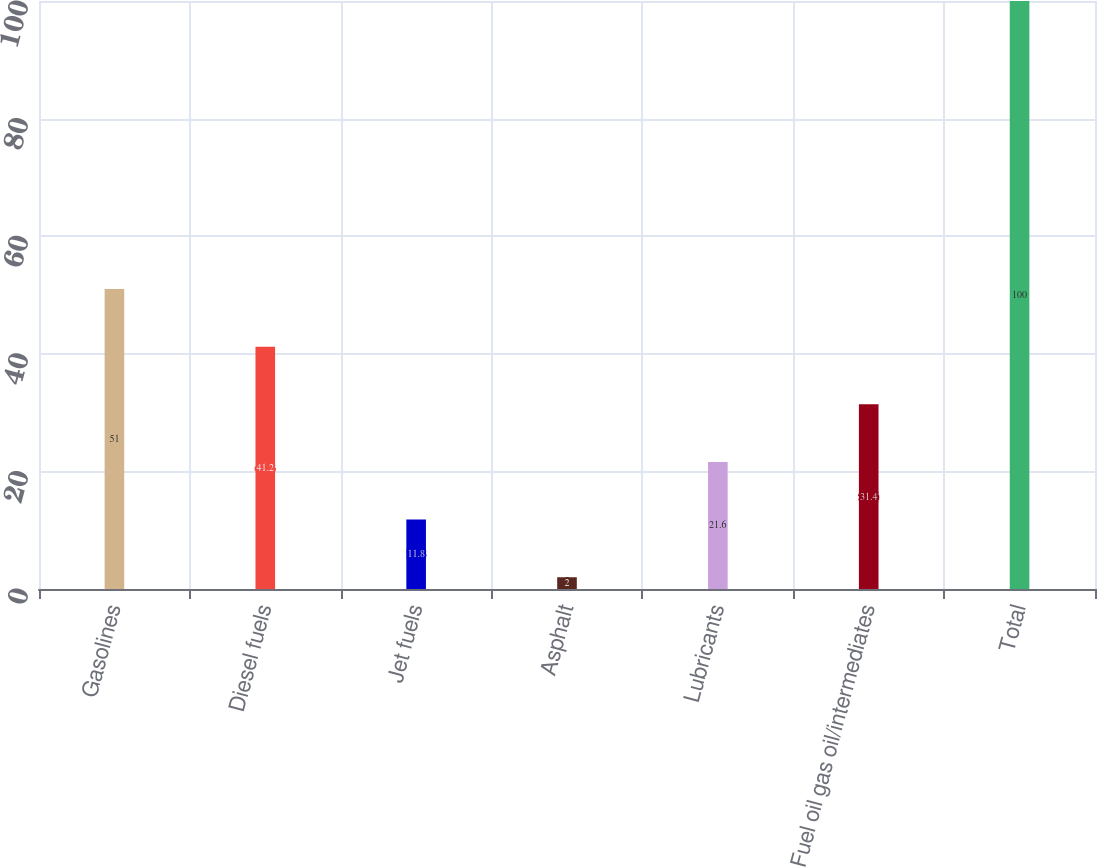<chart> <loc_0><loc_0><loc_500><loc_500><bar_chart><fcel>Gasolines<fcel>Diesel fuels<fcel>Jet fuels<fcel>Asphalt<fcel>Lubricants<fcel>Fuel oil gas oil/intermediates<fcel>Total<nl><fcel>51<fcel>41.2<fcel>11.8<fcel>2<fcel>21.6<fcel>31.4<fcel>100<nl></chart> 